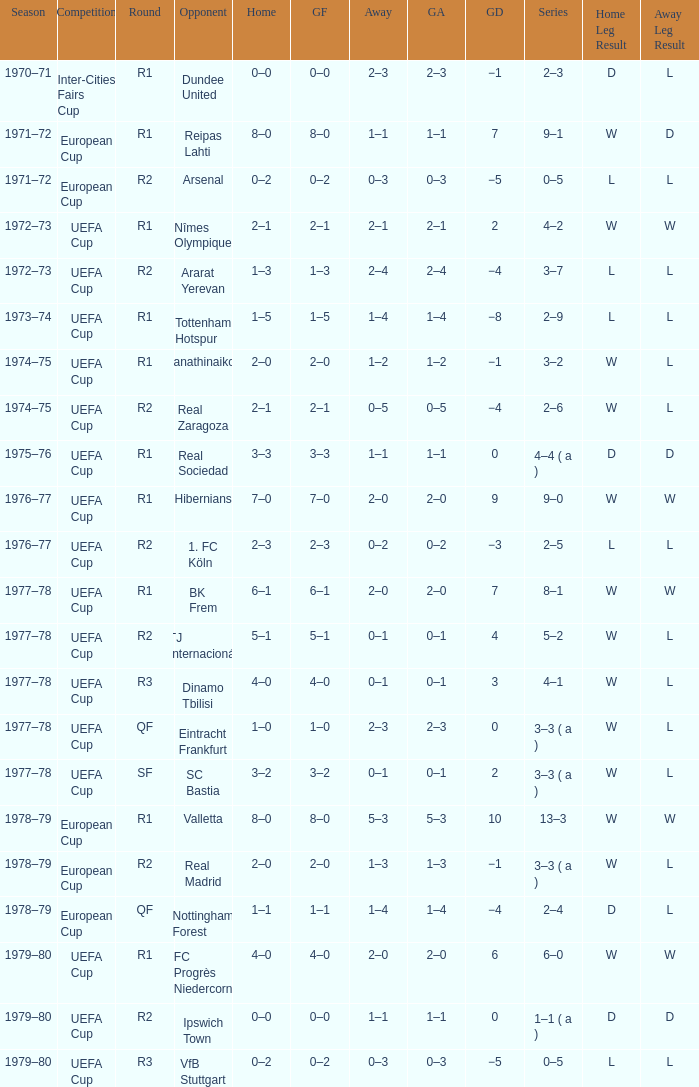Which Series has a Home of 2–0, and an Opponent of panathinaikos? 3–2. Help me parse the entirety of this table. {'header': ['Season', 'Competition', 'Round', 'Opponent', 'Home', 'GF', 'Away', 'GA', 'GD', 'Series', 'Home Leg Result', 'Away Leg Result'], 'rows': [['1970–71', 'Inter-Cities Fairs Cup', 'R1', 'Dundee United', '0–0', '0–0', '2–3', '2–3', '−1', '2–3', 'D', 'L'], ['1971–72', 'European Cup', 'R1', 'Reipas Lahti', '8–0', '8–0', '1–1', '1–1', '7', '9–1', 'W', 'D'], ['1971–72', 'European Cup', 'R2', 'Arsenal', '0–2', '0–2', '0–3', '0–3', '−5', '0–5', 'L', 'L'], ['1972–73', 'UEFA Cup', 'R1', 'Nîmes Olympique', '2–1', '2–1', '2–1', '2–1', '2', '4–2', 'W', 'W'], ['1972–73', 'UEFA Cup', 'R2', 'Ararat Yerevan', '1–3', '1–3', '2–4', '2–4', '−4', '3–7', 'L', 'L'], ['1973–74', 'UEFA Cup', 'R1', 'Tottenham Hotspur', '1–5', '1–5', '1–4', '1–4', '−8', '2–9', 'L', 'L'], ['1974–75', 'UEFA Cup', 'R1', 'Panathinaikos', '2–0', '2–0', '1–2', '1–2', '−1', '3–2', 'W', 'L'], ['1974–75', 'UEFA Cup', 'R2', 'Real Zaragoza', '2–1', '2–1', '0–5', '0–5', '−4', '2–6', 'W', 'L'], ['1975–76', 'UEFA Cup', 'R1', 'Real Sociedad', '3–3', '3–3', '1–1', '1–1', '0', '4–4 ( a )', 'D', 'D'], ['1976–77', 'UEFA Cup', 'R1', 'Hibernians', '7–0', '7–0', '2–0', '2–0', '9', '9–0', 'W', 'W'], ['1976–77', 'UEFA Cup', 'R2', '1. FC Köln', '2–3', '2–3', '0–2', '0–2', '−3', '2–5', 'L', 'L'], ['1977–78', 'UEFA Cup', 'R1', 'BK Frem', '6–1', '6–1', '2–0', '2–0', '7', '8–1', 'W', 'W'], ['1977–78', 'UEFA Cup', 'R2', 'TJ Internacionál', '5–1', '5–1', '0–1', '0–1', '4', '5–2', 'W', 'L'], ['1977–78', 'UEFA Cup', 'R3', 'Dinamo Tbilisi', '4–0', '4–0', '0–1', '0–1', '3', '4–1', 'W', 'L'], ['1977–78', 'UEFA Cup', 'QF', 'Eintracht Frankfurt', '1–0', '1–0', '2–3', '2–3', '0', '3–3 ( a )', 'W', 'L'], ['1977–78', 'UEFA Cup', 'SF', 'SC Bastia', '3–2', '3–2', '0–1', '0–1', '2', '3–3 ( a )', 'W', 'L'], ['1978–79', 'European Cup', 'R1', 'Valletta', '8–0', '8–0', '5–3', '5–3', '10', '13–3', 'W', 'W'], ['1978–79', 'European Cup', 'R2', 'Real Madrid', '2–0', '2–0', '1–3', '1–3', '−1', '3–3 ( a )', 'W', 'L'], ['1978–79', 'European Cup', 'QF', 'Nottingham Forest', '1–1', '1–1', '1–4', '1–4', '−4', '2–4', 'D', 'L'], ['1979–80', 'UEFA Cup', 'R1', 'FC Progrès Niedercorn', '4–0', '4–0', '2–0', '2–0', '6', '6–0', 'W', 'W'], ['1979–80', 'UEFA Cup', 'R2', 'Ipswich Town', '0–0', '0–0', '1–1', '1–1', '0', '1–1 ( a )', 'D', 'D'], ['1979–80', 'UEFA Cup', 'R3', 'VfB Stuttgart', '0–2', '0–2', '0–3', '0–3', '−5', '0–5', 'L', 'L']]} 